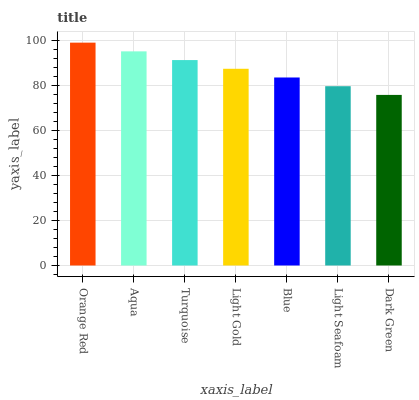Is Dark Green the minimum?
Answer yes or no. Yes. Is Orange Red the maximum?
Answer yes or no. Yes. Is Aqua the minimum?
Answer yes or no. No. Is Aqua the maximum?
Answer yes or no. No. Is Orange Red greater than Aqua?
Answer yes or no. Yes. Is Aqua less than Orange Red?
Answer yes or no. Yes. Is Aqua greater than Orange Red?
Answer yes or no. No. Is Orange Red less than Aqua?
Answer yes or no. No. Is Light Gold the high median?
Answer yes or no. Yes. Is Light Gold the low median?
Answer yes or no. Yes. Is Orange Red the high median?
Answer yes or no. No. Is Light Seafoam the low median?
Answer yes or no. No. 